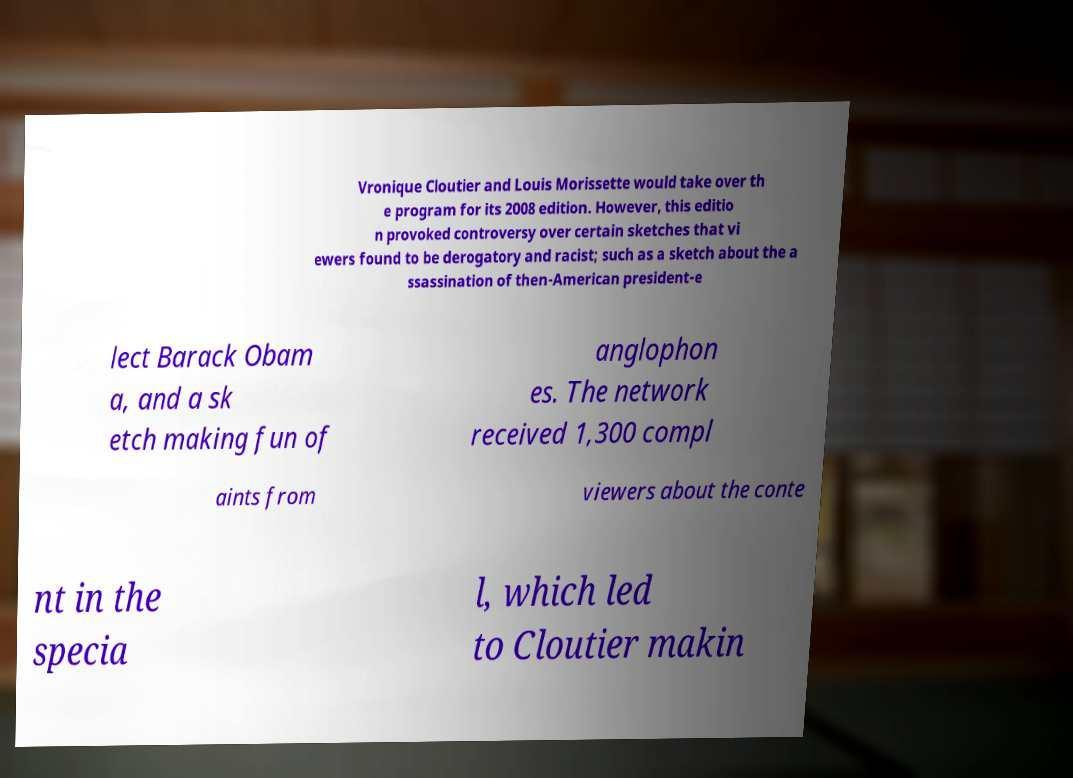For documentation purposes, I need the text within this image transcribed. Could you provide that? Vronique Cloutier and Louis Morissette would take over th e program for its 2008 edition. However, this editio n provoked controversy over certain sketches that vi ewers found to be derogatory and racist; such as a sketch about the a ssassination of then-American president-e lect Barack Obam a, and a sk etch making fun of anglophon es. The network received 1,300 compl aints from viewers about the conte nt in the specia l, which led to Cloutier makin 